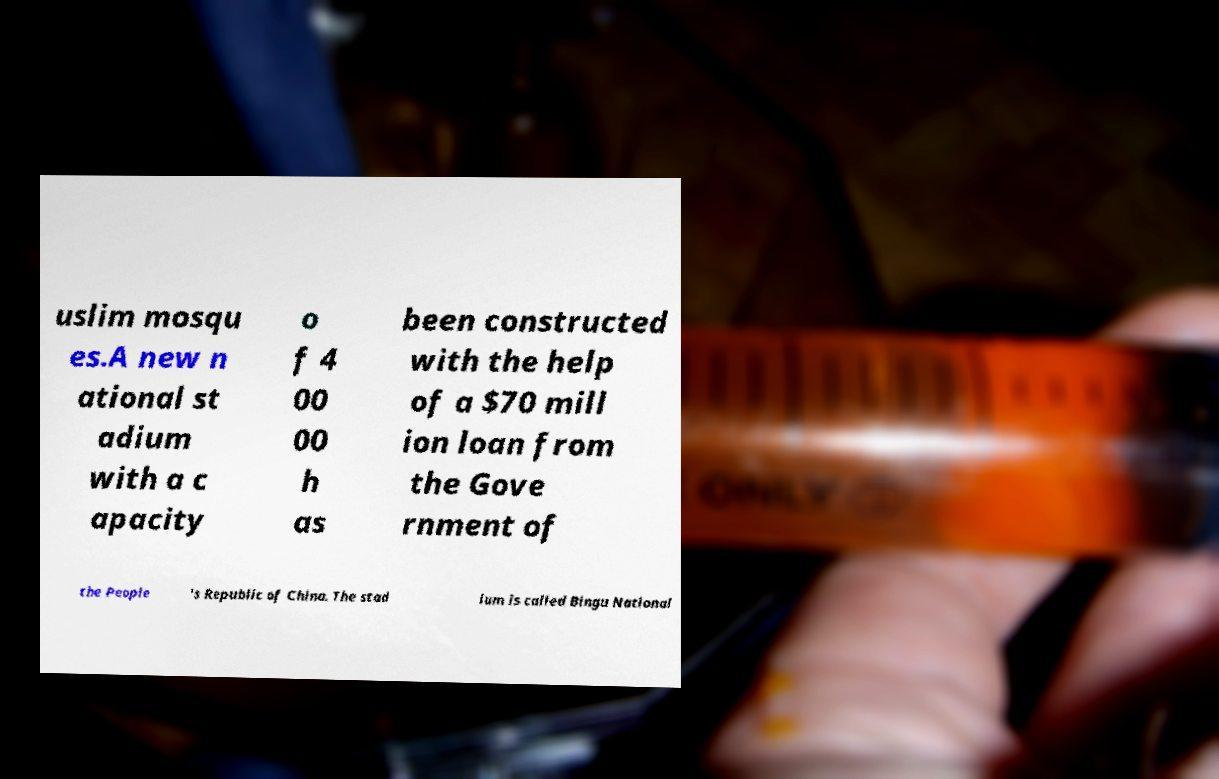Please read and relay the text visible in this image. What does it say? uslim mosqu es.A new n ational st adium with a c apacity o f 4 00 00 h as been constructed with the help of a $70 mill ion loan from the Gove rnment of the People 's Republic of China. The stad ium is called Bingu National 